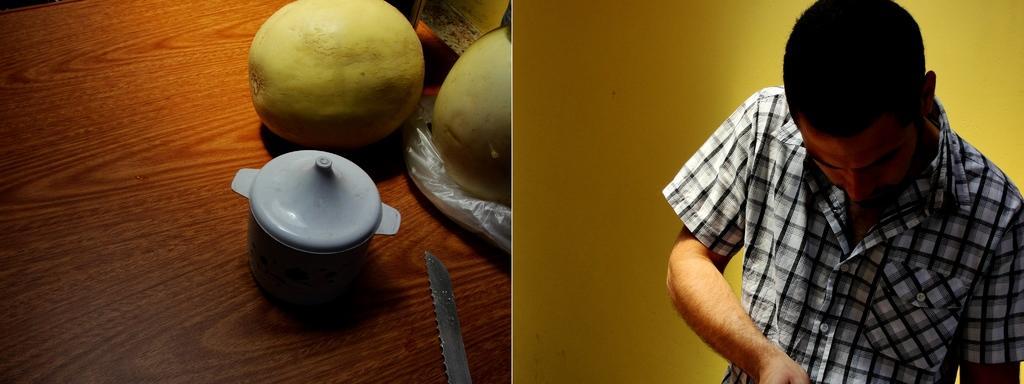In one or two sentences, can you explain what this image depicts? This looks like a collage picture. Here is the man standing. He wore a shirt. This looks like a wall, which is yellow in color. I can see a knife, a box with the lid, fruits and few other things are placed on the wooden board. 